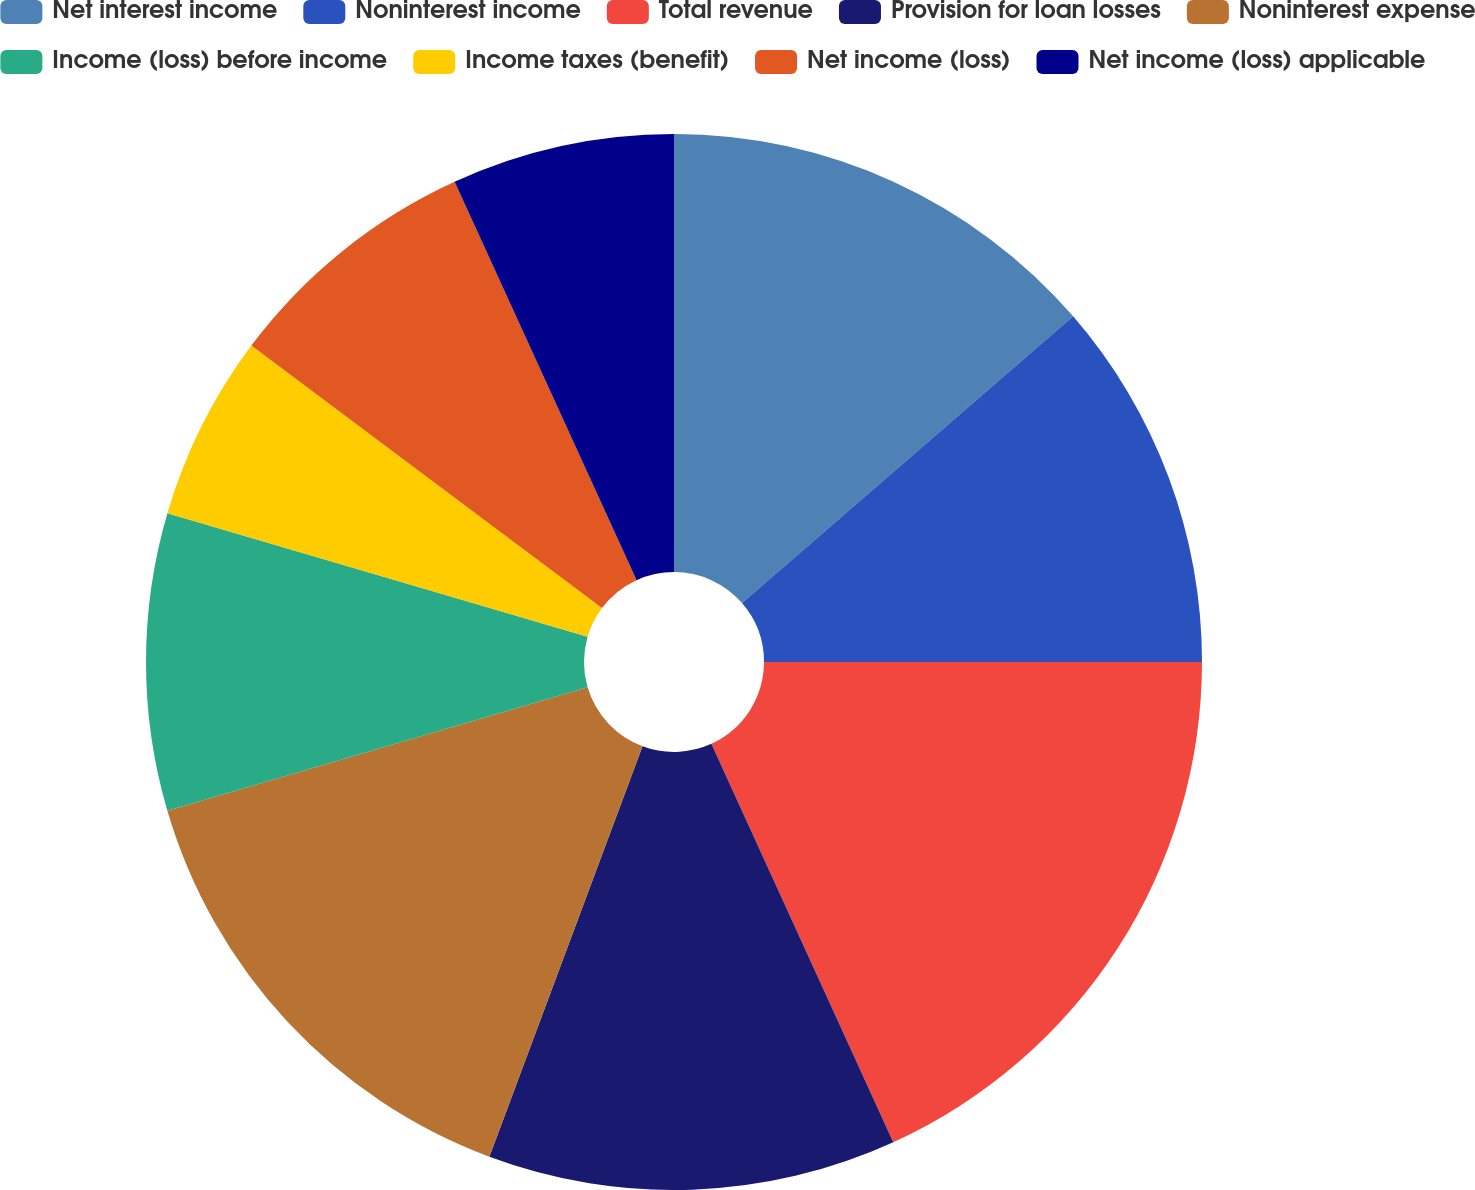Convert chart. <chart><loc_0><loc_0><loc_500><loc_500><pie_chart><fcel>Net interest income<fcel>Noninterest income<fcel>Total revenue<fcel>Provision for loan losses<fcel>Noninterest expense<fcel>Income (loss) before income<fcel>Income taxes (benefit)<fcel>Net income (loss)<fcel>Net income (loss) applicable<nl><fcel>13.64%<fcel>11.36%<fcel>18.18%<fcel>12.5%<fcel>14.77%<fcel>9.09%<fcel>5.68%<fcel>7.95%<fcel>6.82%<nl></chart> 